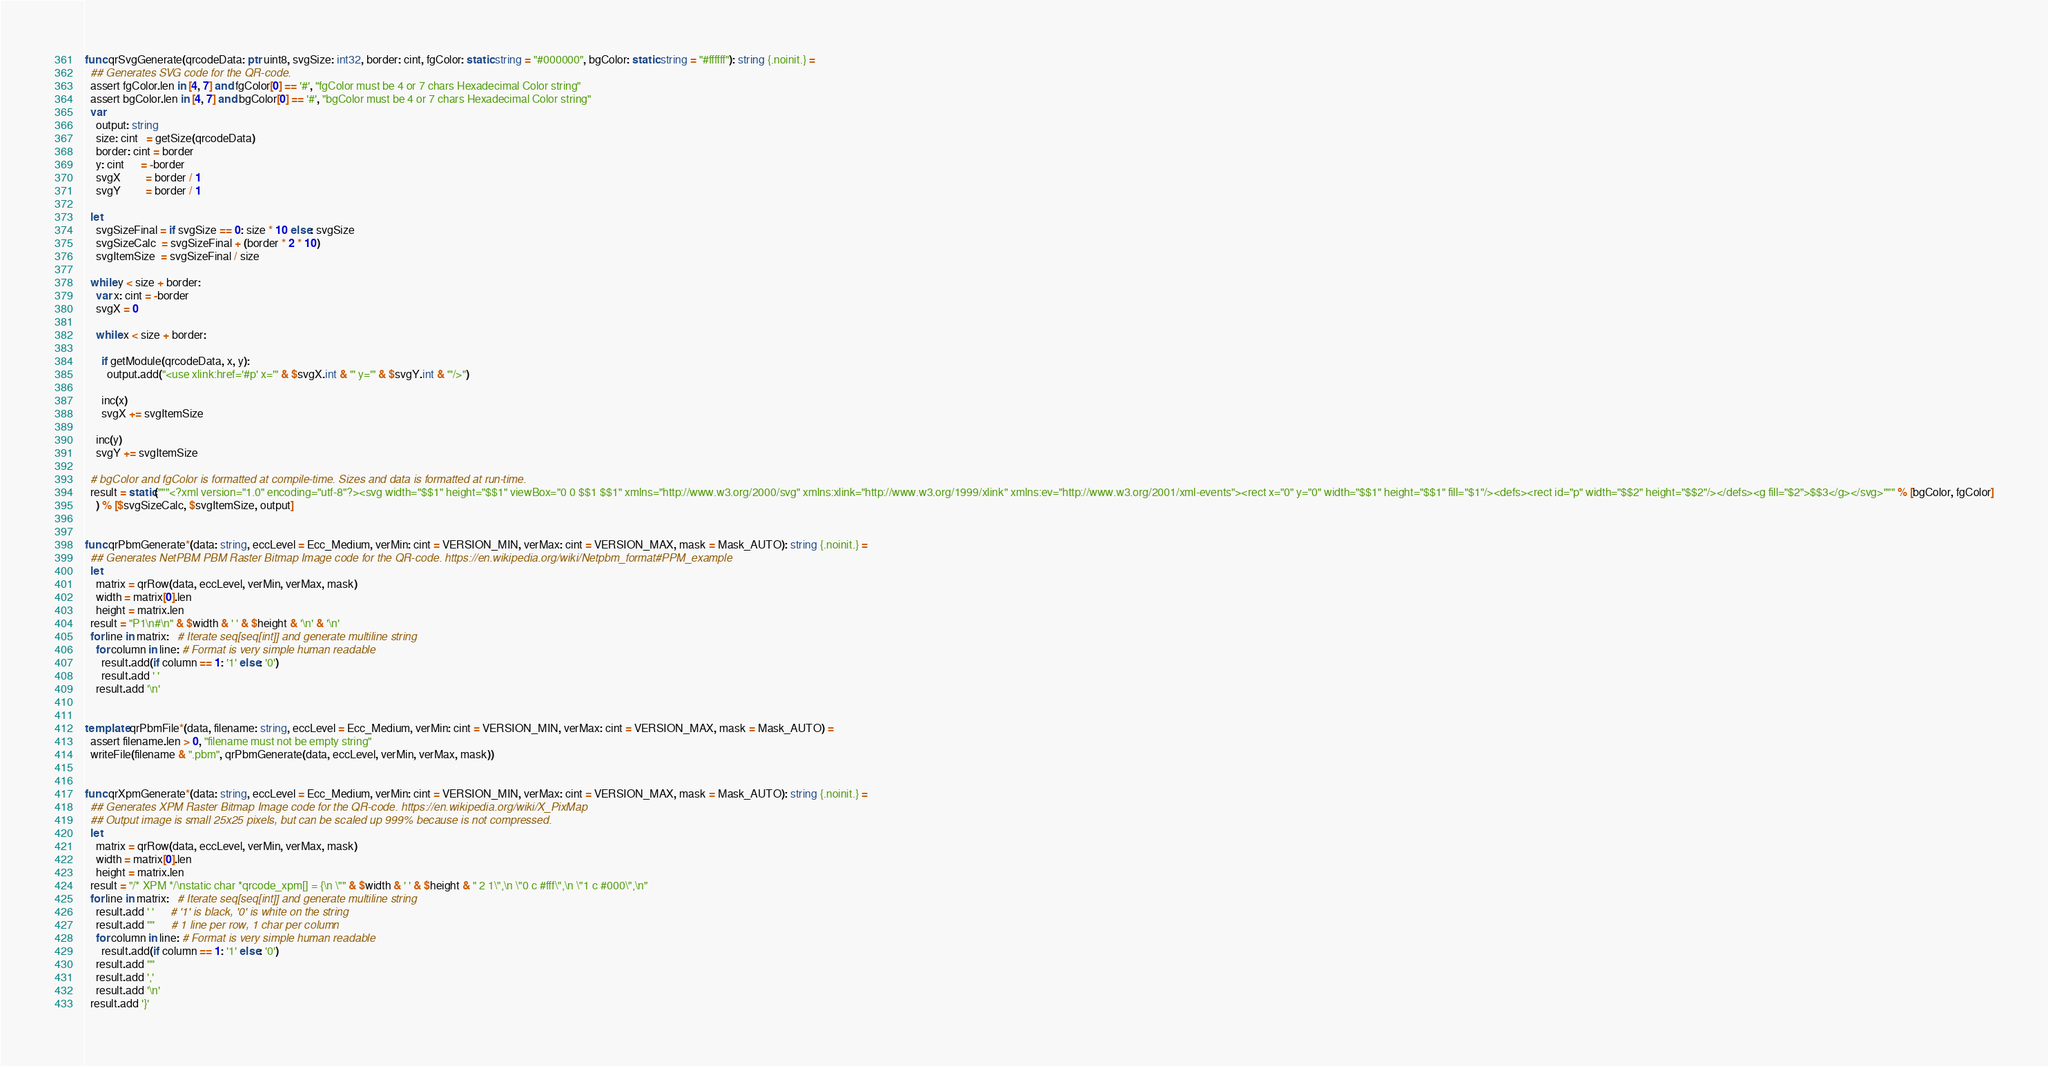Convert code to text. <code><loc_0><loc_0><loc_500><loc_500><_Nim_>

func qrSvgGenerate(qrcodeData: ptr uint8, svgSize: int32, border: cint, fgColor: static string = "#000000", bgColor: static string = "#ffffff"): string {.noinit.} =
  ## Generates SVG code for the QR-code.
  assert fgColor.len in [4, 7] and fgColor[0] == '#', "fgColor must be 4 or 7 chars Hexadecimal Color string"
  assert bgColor.len in [4, 7] and bgColor[0] == '#', "bgColor must be 4 or 7 chars Hexadecimal Color string"
  var
    output: string
    size: cint   = getSize(qrcodeData)
    border: cint = border
    y: cint      = -border
    svgX         = border / 1
    svgY         = border / 1

  let
    svgSizeFinal = if svgSize == 0: size * 10 else: svgSize
    svgSizeCalc  = svgSizeFinal + (border * 2 * 10)
    svgItemSize  = svgSizeFinal / size

  while y < size + border:
    var x: cint = -border
    svgX = 0

    while x < size + border:

      if getModule(qrcodeData, x, y):
        output.add("<use xlink:href='#p' x='" & $svgX.int & "' y='" & $svgY.int & "'/>")

      inc(x)
      svgX += svgItemSize

    inc(y)
    svgY += svgItemSize

  # bgColor and fgColor is formatted at compile-time. Sizes and data is formatted at run-time.
  result = static("""<?xml version="1.0" encoding="utf-8"?><svg width="$$1" height="$$1" viewBox="0 0 $$1 $$1" xmlns="http://www.w3.org/2000/svg" xmlns:xlink="http://www.w3.org/1999/xlink" xmlns:ev="http://www.w3.org/2001/xml-events"><rect x="0" y="0" width="$$1" height="$$1" fill="$1"/><defs><rect id="p" width="$$2" height="$$2"/></defs><g fill="$2">$$3</g></svg>""" % [bgColor, fgColor]
    ) % [$svgSizeCalc, $svgItemSize, output]


func qrPbmGenerate*(data: string, eccLevel = Ecc_Medium, verMin: cint = VERSION_MIN, verMax: cint = VERSION_MAX, mask = Mask_AUTO): string {.noinit.} =
  ## Generates NetPBM PBM Raster Bitmap Image code for the QR-code. https://en.wikipedia.org/wiki/Netpbm_format#PPM_example
  let
    matrix = qrRow(data, eccLevel, verMin, verMax, mask)
    width = matrix[0].len
    height = matrix.len
  result = "P1\n#\n" & $width & ' ' & $height & '\n' & '\n'
  for line in matrix:   # Iterate seq[seq[int]] and generate multiline string
    for column in line: # Format is very simple human readable
      result.add(if column == 1: '1' else: '0')
      result.add ' '
    result.add '\n'


template qrPbmFile*(data, filename: string, eccLevel = Ecc_Medium, verMin: cint = VERSION_MIN, verMax: cint = VERSION_MAX, mask = Mask_AUTO) =
  assert filename.len > 0, "filename must not be empty string"
  writeFile(filename & ".pbm", qrPbmGenerate(data, eccLevel, verMin, verMax, mask))


func qrXpmGenerate*(data: string, eccLevel = Ecc_Medium, verMin: cint = VERSION_MIN, verMax: cint = VERSION_MAX, mask = Mask_AUTO): string {.noinit.} =
  ## Generates XPM Raster Bitmap Image code for the QR-code. https://en.wikipedia.org/wiki/X_PixMap
  ## Output image is small 25x25 pixels, but can be scaled up 999% because is not compressed.
  let
    matrix = qrRow(data, eccLevel, verMin, verMax, mask)
    width = matrix[0].len
    height = matrix.len
  result = "/* XPM */\nstatic char *qrcode_xpm[] = {\n \"" & $width & ' ' & $height & " 2 1\",\n \"0 c #fff\",\n \"1 c #000\",\n"
  for line in matrix:   # Iterate seq[seq[int]] and generate multiline string
    result.add ' '      # '1' is black, '0' is white on the string
    result.add '"'      # 1 line per row, 1 char per column
    for column in line: # Format is very simple human readable
      result.add(if column == 1: '1' else: '0')
    result.add '"'
    result.add ','
    result.add '\n'
  result.add '}'</code> 